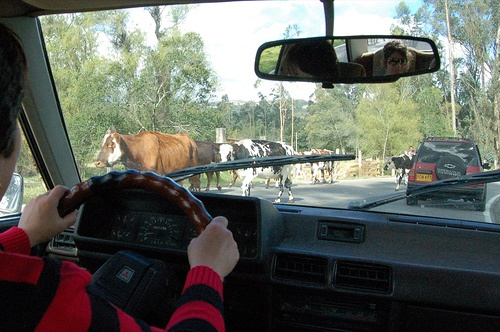Describe the objects in this image and their specific colors. I can see car in black, white, darkgray, gray, and olive tones, people in black, maroon, and gray tones, car in black, gray, purple, and brown tones, cow in black, tan, and gray tones, and cow in black, white, gray, darkgray, and beige tones in this image. 